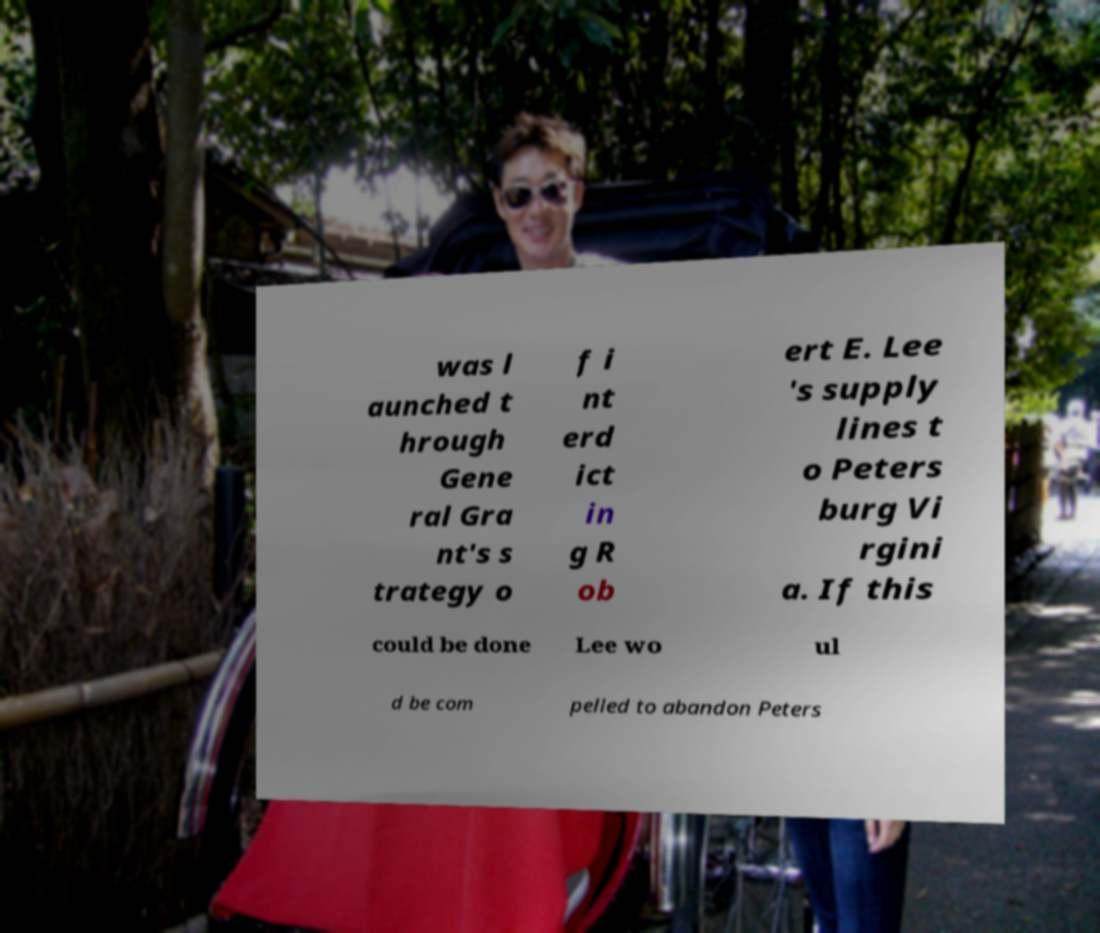For documentation purposes, I need the text within this image transcribed. Could you provide that? was l aunched t hrough Gene ral Gra nt's s trategy o f i nt erd ict in g R ob ert E. Lee 's supply lines t o Peters burg Vi rgini a. If this could be done Lee wo ul d be com pelled to abandon Peters 